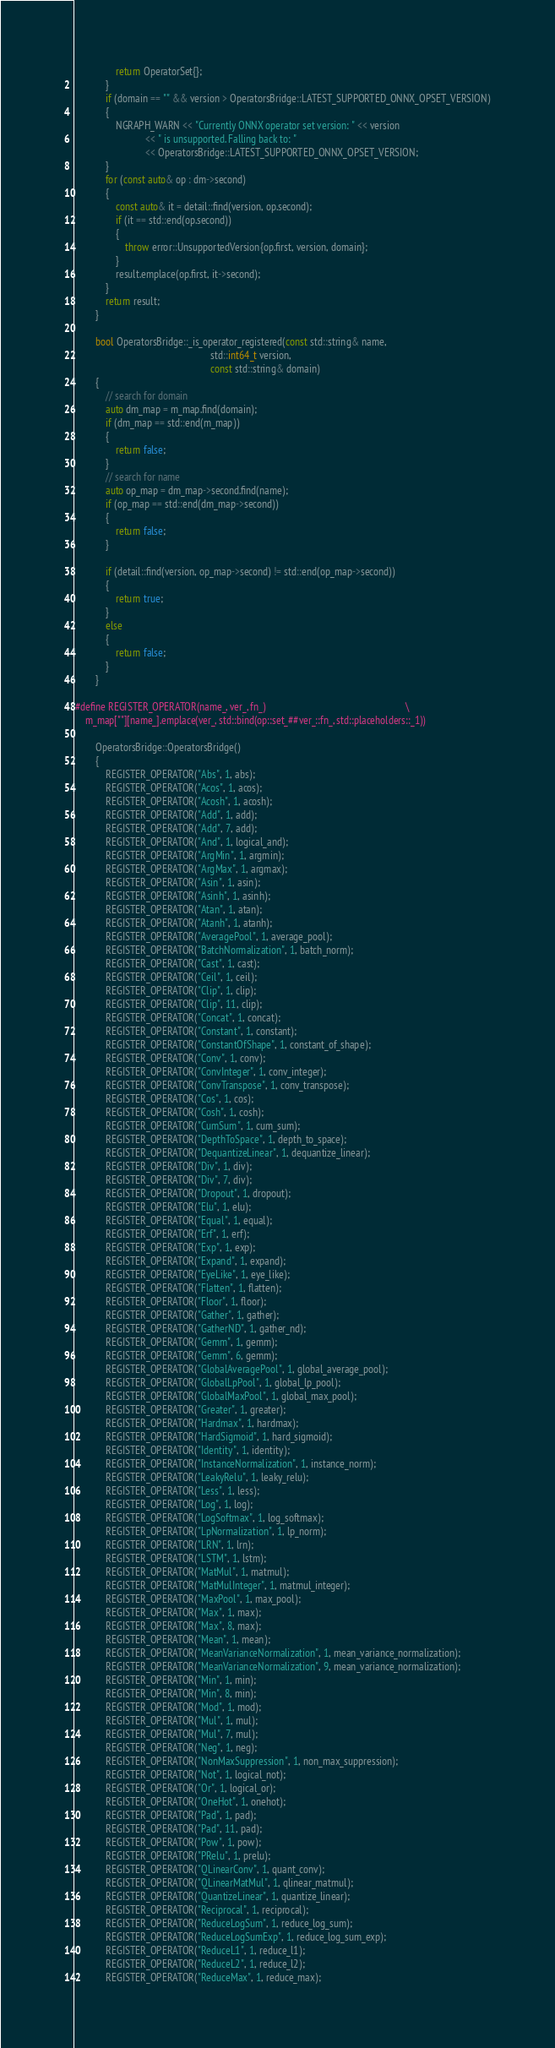Convert code to text. <code><loc_0><loc_0><loc_500><loc_500><_C++_>                return OperatorSet{};
            }
            if (domain == "" && version > OperatorsBridge::LATEST_SUPPORTED_ONNX_OPSET_VERSION)
            {
                NGRAPH_WARN << "Currently ONNX operator set version: " << version
                            << " is unsupported. Falling back to: "
                            << OperatorsBridge::LATEST_SUPPORTED_ONNX_OPSET_VERSION;
            }
            for (const auto& op : dm->second)
            {
                const auto& it = detail::find(version, op.second);
                if (it == std::end(op.second))
                {
                    throw error::UnsupportedVersion{op.first, version, domain};
                }
                result.emplace(op.first, it->second);
            }
            return result;
        }

        bool OperatorsBridge::_is_operator_registered(const std::string& name,
                                                      std::int64_t version,
                                                      const std::string& domain)
        {
            // search for domain
            auto dm_map = m_map.find(domain);
            if (dm_map == std::end(m_map))
            {
                return false;
            }
            // search for name
            auto op_map = dm_map->second.find(name);
            if (op_map == std::end(dm_map->second))
            {
                return false;
            }

            if (detail::find(version, op_map->second) != std::end(op_map->second))
            {
                return true;
            }
            else
            {
                return false;
            }
        }

#define REGISTER_OPERATOR(name_, ver_, fn_)                                                        \
    m_map[""][name_].emplace(ver_, std::bind(op::set_##ver_::fn_, std::placeholders::_1))

        OperatorsBridge::OperatorsBridge()
        {
            REGISTER_OPERATOR("Abs", 1, abs);
            REGISTER_OPERATOR("Acos", 1, acos);
            REGISTER_OPERATOR("Acosh", 1, acosh);
            REGISTER_OPERATOR("Add", 1, add);
            REGISTER_OPERATOR("Add", 7, add);
            REGISTER_OPERATOR("And", 1, logical_and);
            REGISTER_OPERATOR("ArgMin", 1, argmin);
            REGISTER_OPERATOR("ArgMax", 1, argmax);
            REGISTER_OPERATOR("Asin", 1, asin);
            REGISTER_OPERATOR("Asinh", 1, asinh);
            REGISTER_OPERATOR("Atan", 1, atan);
            REGISTER_OPERATOR("Atanh", 1, atanh);
            REGISTER_OPERATOR("AveragePool", 1, average_pool);
            REGISTER_OPERATOR("BatchNormalization", 1, batch_norm);
            REGISTER_OPERATOR("Cast", 1, cast);
            REGISTER_OPERATOR("Ceil", 1, ceil);
            REGISTER_OPERATOR("Clip", 1, clip);
            REGISTER_OPERATOR("Clip", 11, clip);
            REGISTER_OPERATOR("Concat", 1, concat);
            REGISTER_OPERATOR("Constant", 1, constant);
            REGISTER_OPERATOR("ConstantOfShape", 1, constant_of_shape);
            REGISTER_OPERATOR("Conv", 1, conv);
            REGISTER_OPERATOR("ConvInteger", 1, conv_integer);
            REGISTER_OPERATOR("ConvTranspose", 1, conv_transpose);
            REGISTER_OPERATOR("Cos", 1, cos);
            REGISTER_OPERATOR("Cosh", 1, cosh);
            REGISTER_OPERATOR("CumSum", 1, cum_sum);
            REGISTER_OPERATOR("DepthToSpace", 1, depth_to_space);
            REGISTER_OPERATOR("DequantizeLinear", 1, dequantize_linear);
            REGISTER_OPERATOR("Div", 1, div);
            REGISTER_OPERATOR("Div", 7, div);
            REGISTER_OPERATOR("Dropout", 1, dropout);
            REGISTER_OPERATOR("Elu", 1, elu);
            REGISTER_OPERATOR("Equal", 1, equal);
            REGISTER_OPERATOR("Erf", 1, erf);
            REGISTER_OPERATOR("Exp", 1, exp);
            REGISTER_OPERATOR("Expand", 1, expand);
            REGISTER_OPERATOR("EyeLike", 1, eye_like);
            REGISTER_OPERATOR("Flatten", 1, flatten);
            REGISTER_OPERATOR("Floor", 1, floor);
            REGISTER_OPERATOR("Gather", 1, gather);
            REGISTER_OPERATOR("GatherND", 1, gather_nd);
            REGISTER_OPERATOR("Gemm", 1, gemm);
            REGISTER_OPERATOR("Gemm", 6, gemm);
            REGISTER_OPERATOR("GlobalAveragePool", 1, global_average_pool);
            REGISTER_OPERATOR("GlobalLpPool", 1, global_lp_pool);
            REGISTER_OPERATOR("GlobalMaxPool", 1, global_max_pool);
            REGISTER_OPERATOR("Greater", 1, greater);
            REGISTER_OPERATOR("Hardmax", 1, hardmax);
            REGISTER_OPERATOR("HardSigmoid", 1, hard_sigmoid);
            REGISTER_OPERATOR("Identity", 1, identity);
            REGISTER_OPERATOR("InstanceNormalization", 1, instance_norm);
            REGISTER_OPERATOR("LeakyRelu", 1, leaky_relu);
            REGISTER_OPERATOR("Less", 1, less);
            REGISTER_OPERATOR("Log", 1, log);
            REGISTER_OPERATOR("LogSoftmax", 1, log_softmax);
            REGISTER_OPERATOR("LpNormalization", 1, lp_norm);
            REGISTER_OPERATOR("LRN", 1, lrn);
            REGISTER_OPERATOR("LSTM", 1, lstm);
            REGISTER_OPERATOR("MatMul", 1, matmul);
            REGISTER_OPERATOR("MatMulInteger", 1, matmul_integer);
            REGISTER_OPERATOR("MaxPool", 1, max_pool);
            REGISTER_OPERATOR("Max", 1, max);
            REGISTER_OPERATOR("Max", 8, max);
            REGISTER_OPERATOR("Mean", 1, mean);
            REGISTER_OPERATOR("MeanVarianceNormalization", 1, mean_variance_normalization);
            REGISTER_OPERATOR("MeanVarianceNormalization", 9, mean_variance_normalization);
            REGISTER_OPERATOR("Min", 1, min);
            REGISTER_OPERATOR("Min", 8, min);
            REGISTER_OPERATOR("Mod", 1, mod);
            REGISTER_OPERATOR("Mul", 1, mul);
            REGISTER_OPERATOR("Mul", 7, mul);
            REGISTER_OPERATOR("Neg", 1, neg);
            REGISTER_OPERATOR("NonMaxSuppression", 1, non_max_suppression);
            REGISTER_OPERATOR("Not", 1, logical_not);
            REGISTER_OPERATOR("Or", 1, logical_or);
            REGISTER_OPERATOR("OneHot", 1, onehot);
            REGISTER_OPERATOR("Pad", 1, pad);
            REGISTER_OPERATOR("Pad", 11, pad);
            REGISTER_OPERATOR("Pow", 1, pow);
            REGISTER_OPERATOR("PRelu", 1, prelu);
            REGISTER_OPERATOR("QLinearConv", 1, quant_conv);
            REGISTER_OPERATOR("QLinearMatMul", 1, qlinear_matmul);
            REGISTER_OPERATOR("QuantizeLinear", 1, quantize_linear);
            REGISTER_OPERATOR("Reciprocal", 1, reciprocal);
            REGISTER_OPERATOR("ReduceLogSum", 1, reduce_log_sum);
            REGISTER_OPERATOR("ReduceLogSumExp", 1, reduce_log_sum_exp);
            REGISTER_OPERATOR("ReduceL1", 1, reduce_l1);
            REGISTER_OPERATOR("ReduceL2", 1, reduce_l2);
            REGISTER_OPERATOR("ReduceMax", 1, reduce_max);</code> 